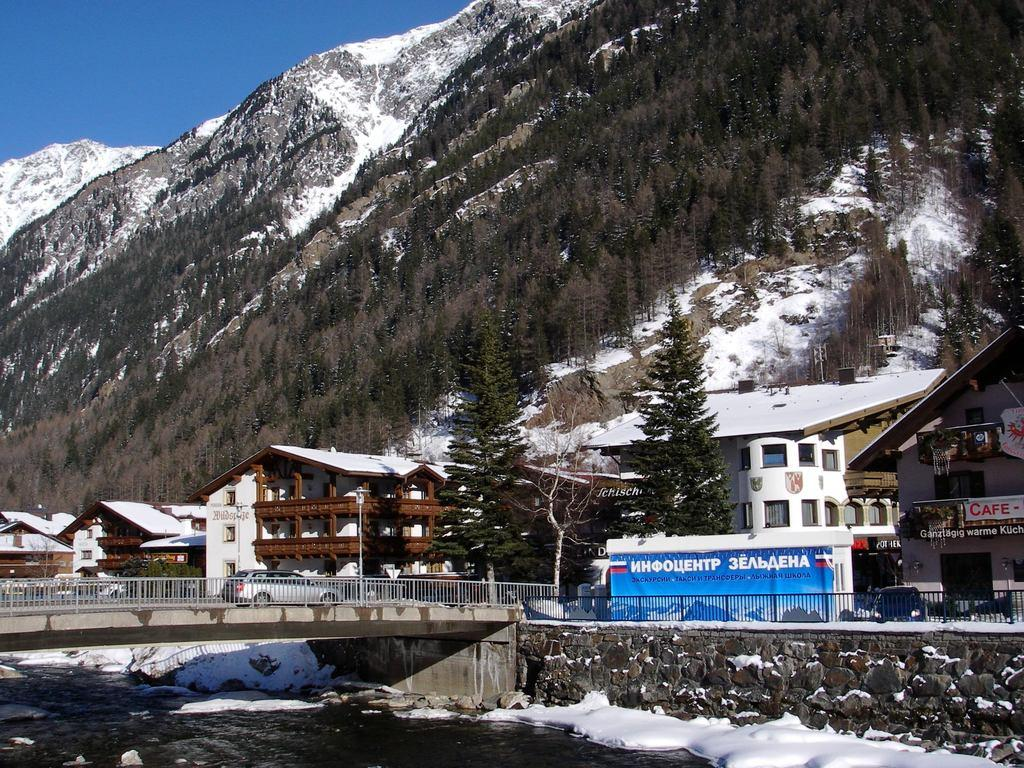What is the primary element visible in the image? There is water in the image. What type of weather condition is depicted in the image? There is snow in the image, indicating a cold or wintry environment. What structure is the car located on in the image? The car is on a bridge in the image. What type of barrier is present in the image? There is a fence in the image. What type of vegetation is visible in the image? There are trees in the image. What type of vertical structures are present in the image? There are poles in the image. What type of man-made structures are visible in the image? There are buildings in the image. What type of natural landform is visible in the background of the image? There are mountains in the background of the image. What part of the natural environment is visible at the top of the image? The sky is visible at the top of the image. How many oranges are hanging from the poles in the image? There are no oranges present in the image; it features a car on a bridge, a fence, trees, poles, buildings, mountains, and a sky. What is the interest rate of the loan taken out to build the bridge in the image? There is no information about loans or interest rates in the image; it simply shows a car on a bridge. 